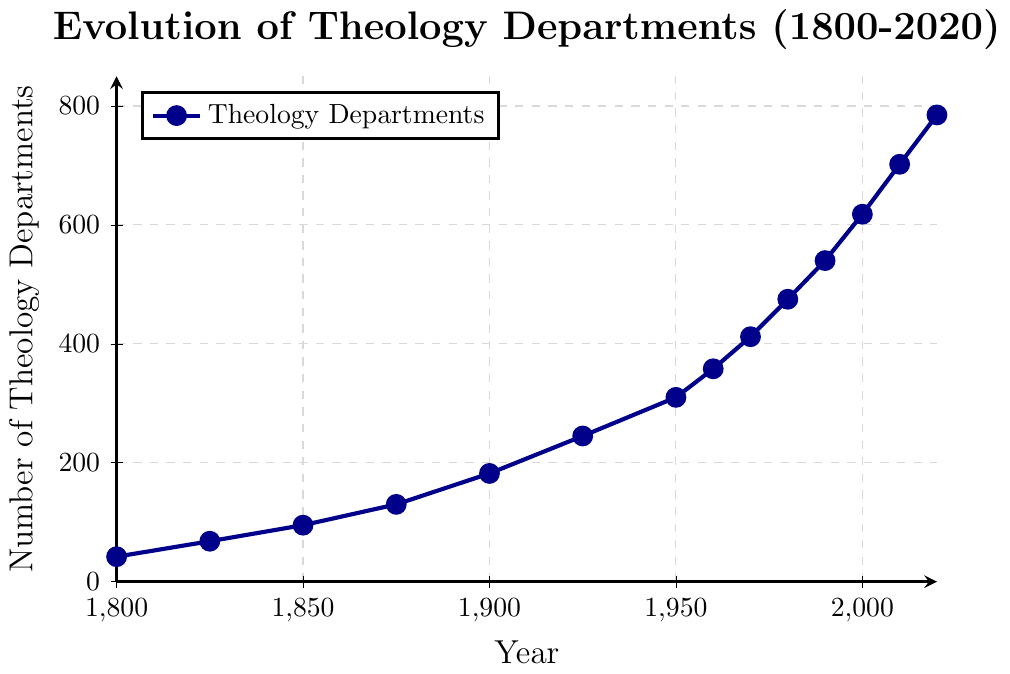What is the number of theology departments in 1875? Locate the year 1875 on the x-axis and find the corresponding value on the y-axis, which represents the number of theology departments.
Answer: 130 Between which two years did the number of theology departments increase the most? Compare the increments between consecutive data points by subtracting the number of departments in the earlier year from the later year. The largest increase is between 2000 and 2010, with an increase of 84 departments.
Answer: Between 2000 and 2010 During which decade did the number of theology departments first surpass 400? Look at the y-axis values above 400 and trace them back to the corresponding x-axis values. The number surpassed 400 in the decade between 1960 and 1970.
Answer: 1970s What visual attribute helps to quickly identify the trend in the data? The use of a solid dark blue line with marked data points visually emphasizes the upward trend in the number of theology departments over time.
Answer: The solid dark blue line with marked data points Which decade saw the lowest increase in the number of theology departments, according to the plot? Comparing the increase in departments across decades, the smallest increase seems to be between 1825 and 1850.
Answer: Between 1825 and 1850 